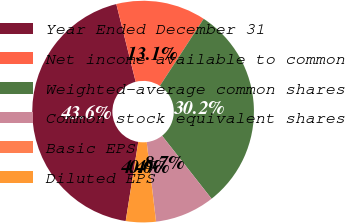<chart> <loc_0><loc_0><loc_500><loc_500><pie_chart><fcel>Year Ended December 31<fcel>Net income available to common<fcel>Weighted-average common shares<fcel>Common stock equivalent shares<fcel>Basic EPS<fcel>Diluted EPS<nl><fcel>43.61%<fcel>13.09%<fcel>30.2%<fcel>8.73%<fcel>0.01%<fcel>4.37%<nl></chart> 